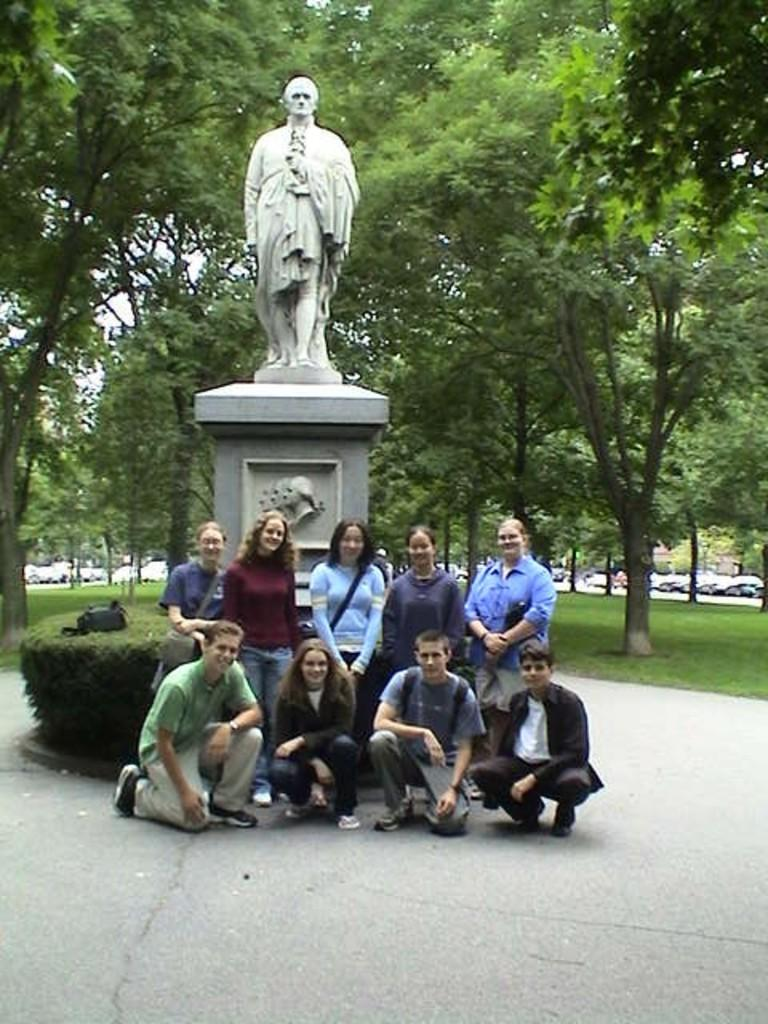What is happening with the group of people in the image? The group of people are taking a photograph. What is located behind the group of people? There is a statue behind the group of people. What type of vegetation can be seen in the image? There are green trees visible in the image. What type of cabbage is being served on a tray in the image? There is no cabbage or tray present in the image. 